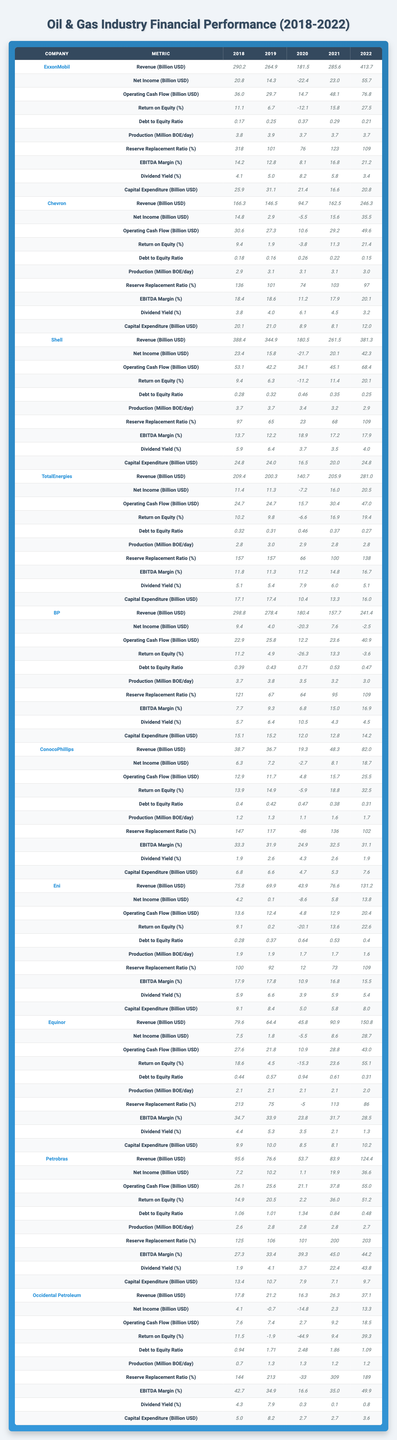What is the Revenue of ExxonMobil in 2022? The table indicates that ExxonMobil generated a Revenue of 413.7 billion USD in 2022.
Answer: 413.7 billion USD Which company had the highest Net Income in 2021? By checking the Net Income values for 2021, it shows that ExxonMobil had the highest Net Income of 23.0 billion USD.
Answer: ExxonMobil What is the average Return on Equity for Shell over the given years? The Return on Equity for Shell is 9.4, 6.3, -11.2, 11.4, and 20.1 across the years. Summing them gives 36.6, and dividing by 5 yields an average of 7.32%.
Answer: 7.32% What was the Debt to Equity Ratio of Eni in 2020? The Debt to Equity Ratio for Eni in 2020 is 0.64 as per the table provided.
Answer: 0.64 How much did TotalEnergies spend on Capital Expenditure in 2021? The amount spent on Capital Expenditure by TotalEnergies in 2021 is 13.3 billion USD, as provided in the table.
Answer: 13.3 billion USD Did Petrobras have a positive Net Income in 2020? The table shows that Petrobras had a Net Income of 1.1 billion USD in 2020, which is positive.
Answer: Yes Which company had the lowest Operating Cash Flow in 2020 and what was it? In 2020, the company with the lowest Operating Cash Flow was ConocoPhillips, with a value of 4.8 billion USD.
Answer: ConocoPhillips, 4.8 billion USD What is the difference in Revenue between Chevron in 2018 and 2022? Chevron’s Revenue in 2018 was 166.3 billion USD and in 2022, it was 246.3 billion USD. The difference is 246.3 – 166.3 = 80 billion USD.
Answer: 80 billion USD Which company showed an increasing trend in Net Income from 2018 to 2022? Upon reviewing the Net Income figures, TotalEnergies reflects an increasing trend from 11.4 billion in 2018 to 20.5 billion in 2022.
Answer: TotalEnergies Calculate the average Dividend Yield for BP from 2018 to 2022. The Dividend Yield values for BP are 5.7, 6.4, 10.5, 4.3, and 4.5 for the respective years. The average is (5.7 + 6.4 + 10.5 + 4.3 + 4.5) / 5 = 6.48%.
Answer: 6.48% 